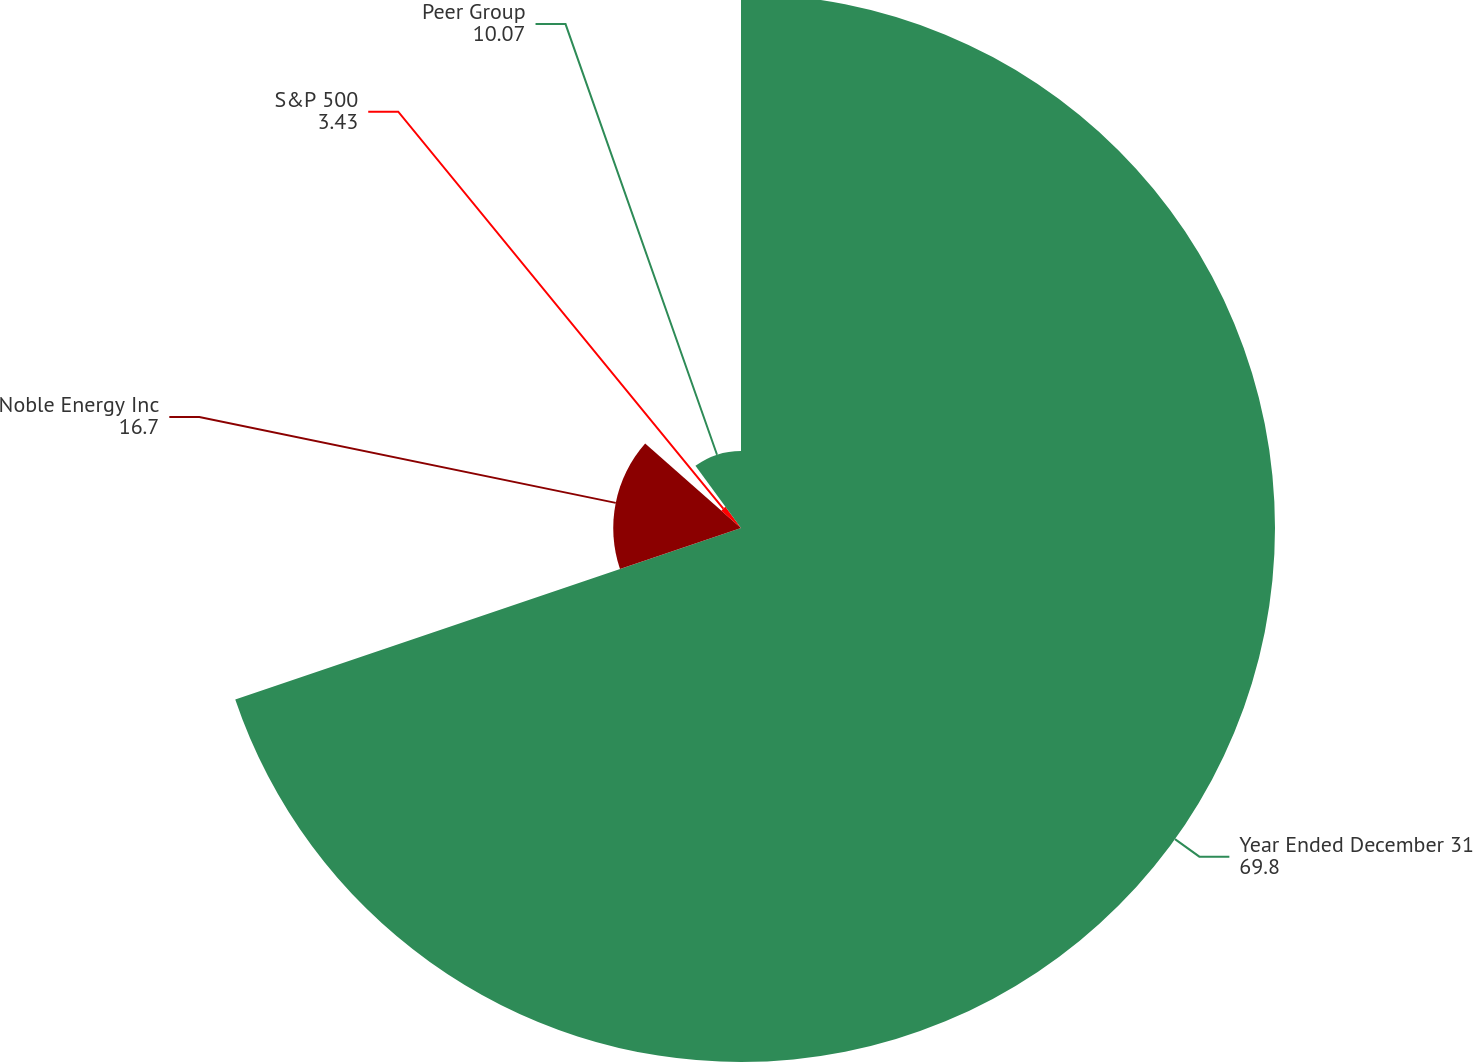<chart> <loc_0><loc_0><loc_500><loc_500><pie_chart><fcel>Year Ended December 31<fcel>Noble Energy Inc<fcel>S&P 500<fcel>Peer Group<nl><fcel>69.8%<fcel>16.7%<fcel>3.43%<fcel>10.07%<nl></chart> 